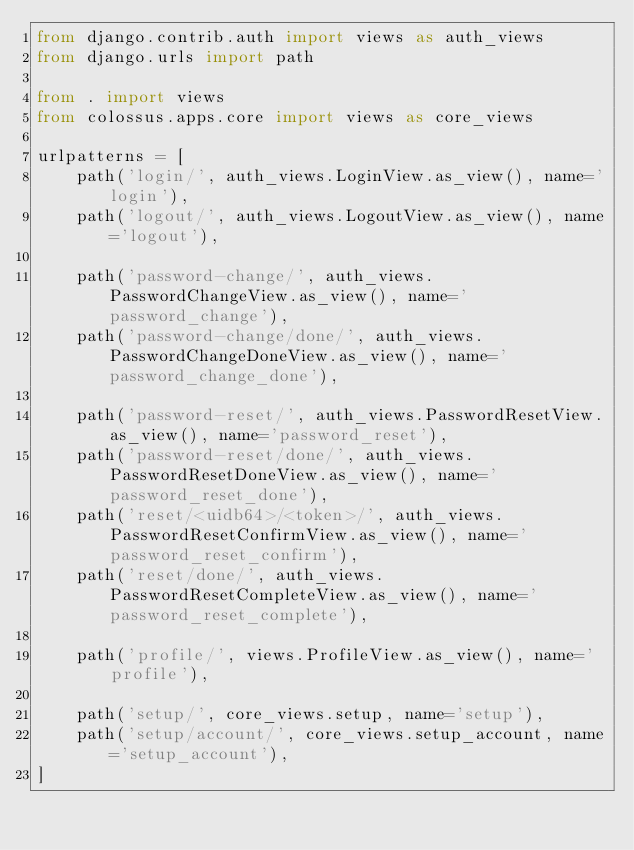<code> <loc_0><loc_0><loc_500><loc_500><_Python_>from django.contrib.auth import views as auth_views
from django.urls import path

from . import views
from colossus.apps.core import views as core_views

urlpatterns = [
    path('login/', auth_views.LoginView.as_view(), name='login'),
    path('logout/', auth_views.LogoutView.as_view(), name='logout'),

    path('password-change/', auth_views.PasswordChangeView.as_view(), name='password_change'),
    path('password-change/done/', auth_views.PasswordChangeDoneView.as_view(), name='password_change_done'),

    path('password-reset/', auth_views.PasswordResetView.as_view(), name='password_reset'),
    path('password-reset/done/', auth_views.PasswordResetDoneView.as_view(), name='password_reset_done'),
    path('reset/<uidb64>/<token>/', auth_views.PasswordResetConfirmView.as_view(), name='password_reset_confirm'),
    path('reset/done/', auth_views.PasswordResetCompleteView.as_view(), name='password_reset_complete'),

    path('profile/', views.ProfileView.as_view(), name='profile'),

    path('setup/', core_views.setup, name='setup'),
    path('setup/account/', core_views.setup_account, name='setup_account'),
]
</code> 